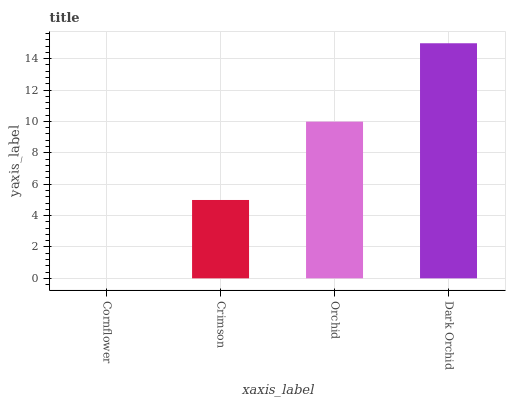Is Cornflower the minimum?
Answer yes or no. Yes. Is Dark Orchid the maximum?
Answer yes or no. Yes. Is Crimson the minimum?
Answer yes or no. No. Is Crimson the maximum?
Answer yes or no. No. Is Crimson greater than Cornflower?
Answer yes or no. Yes. Is Cornflower less than Crimson?
Answer yes or no. Yes. Is Cornflower greater than Crimson?
Answer yes or no. No. Is Crimson less than Cornflower?
Answer yes or no. No. Is Orchid the high median?
Answer yes or no. Yes. Is Crimson the low median?
Answer yes or no. Yes. Is Cornflower the high median?
Answer yes or no. No. Is Orchid the low median?
Answer yes or no. No. 